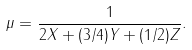Convert formula to latex. <formula><loc_0><loc_0><loc_500><loc_500>\mu = \frac { 1 } { 2 X + ( 3 / 4 ) Y + ( 1 / 2 ) Z } .</formula> 